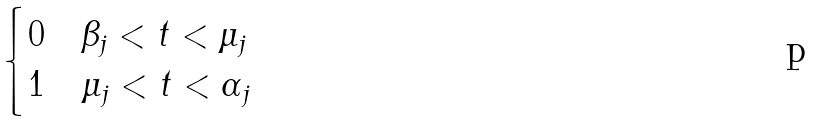<formula> <loc_0><loc_0><loc_500><loc_500>\begin{cases} 0 & \beta _ { j } < t < \mu _ { j } \\ 1 & \mu _ { j } < t < \alpha _ { j } \end{cases}</formula> 